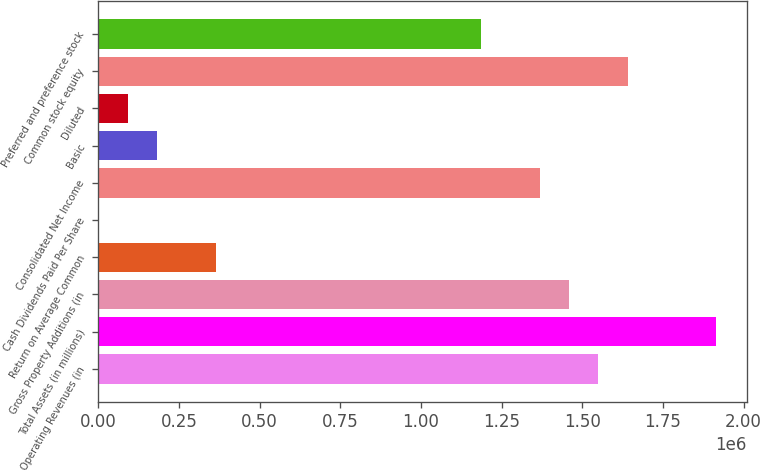Convert chart. <chart><loc_0><loc_0><loc_500><loc_500><bar_chart><fcel>Operating Revenues (in<fcel>Total Assets (in millions)<fcel>Gross Property Additions (in<fcel>Return on Average Common<fcel>Cash Dividends Paid Per Share<fcel>Consolidated Net Income<fcel>Basic<fcel>Diluted<fcel>Common stock equity<fcel>Preferred and preference stock<nl><fcel>1.54992e+06<fcel>1.91461e+06<fcel>1.45875e+06<fcel>364690<fcel>2.15<fcel>1.36758e+06<fcel>182346<fcel>91174<fcel>1.6411e+06<fcel>1.18524e+06<nl></chart> 